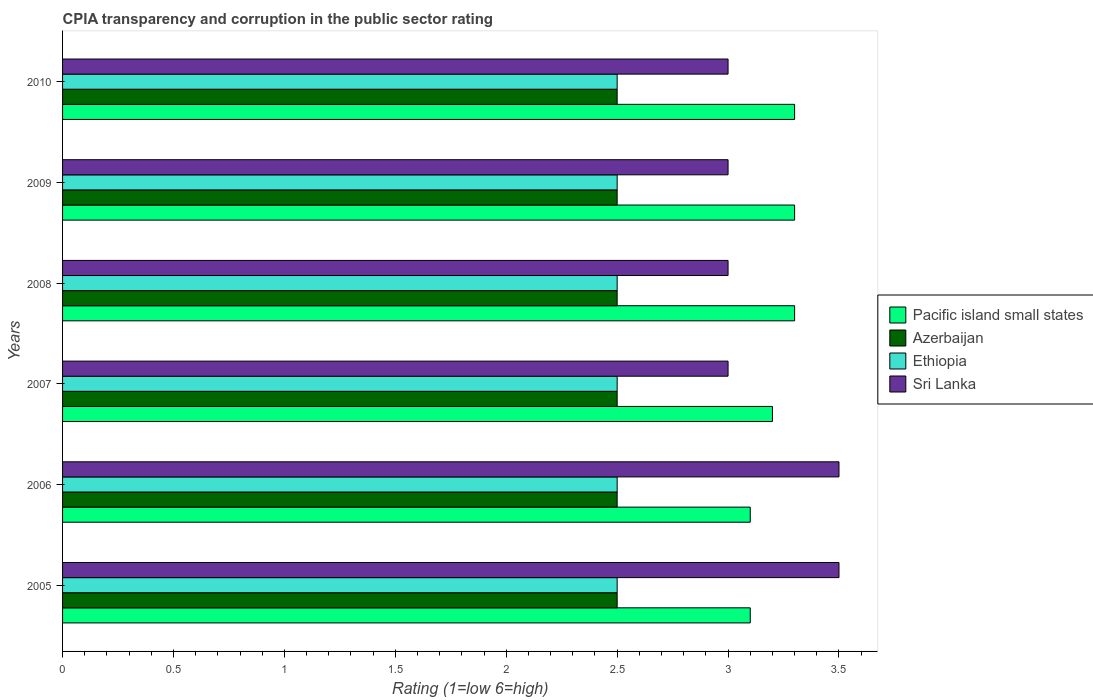How many different coloured bars are there?
Offer a very short reply. 4. Are the number of bars per tick equal to the number of legend labels?
Offer a terse response. Yes. Are the number of bars on each tick of the Y-axis equal?
Provide a short and direct response. Yes. In how many cases, is the number of bars for a given year not equal to the number of legend labels?
Ensure brevity in your answer.  0. What is the CPIA rating in Pacific island small states in 2010?
Provide a succinct answer. 3.3. In which year was the CPIA rating in Pacific island small states maximum?
Give a very brief answer. 2008. In which year was the CPIA rating in Sri Lanka minimum?
Offer a very short reply. 2007. What is the difference between the CPIA rating in Pacific island small states in 2006 and that in 2008?
Ensure brevity in your answer.  -0.2. What is the difference between the CPIA rating in Azerbaijan in 2006 and the CPIA rating in Ethiopia in 2009?
Make the answer very short. 0. What is the average CPIA rating in Azerbaijan per year?
Ensure brevity in your answer.  2.5. In the year 2005, what is the difference between the CPIA rating in Sri Lanka and CPIA rating in Ethiopia?
Your answer should be compact. 1. What is the ratio of the CPIA rating in Azerbaijan in 2005 to that in 2010?
Your answer should be very brief. 1. Is the difference between the CPIA rating in Sri Lanka in 2005 and 2010 greater than the difference between the CPIA rating in Ethiopia in 2005 and 2010?
Your answer should be compact. Yes. What is the difference between the highest and the second highest CPIA rating in Pacific island small states?
Keep it short and to the point. 0. In how many years, is the CPIA rating in Sri Lanka greater than the average CPIA rating in Sri Lanka taken over all years?
Keep it short and to the point. 2. What does the 2nd bar from the top in 2005 represents?
Provide a succinct answer. Ethiopia. What does the 1st bar from the bottom in 2009 represents?
Offer a very short reply. Pacific island small states. How many bars are there?
Offer a terse response. 24. Are all the bars in the graph horizontal?
Offer a terse response. Yes. How many years are there in the graph?
Ensure brevity in your answer.  6. What is the difference between two consecutive major ticks on the X-axis?
Give a very brief answer. 0.5. Does the graph contain any zero values?
Ensure brevity in your answer.  No. How many legend labels are there?
Make the answer very short. 4. What is the title of the graph?
Offer a terse response. CPIA transparency and corruption in the public sector rating. Does "Russian Federation" appear as one of the legend labels in the graph?
Your answer should be compact. No. What is the label or title of the X-axis?
Offer a very short reply. Rating (1=low 6=high). What is the Rating (1=low 6=high) of Ethiopia in 2005?
Keep it short and to the point. 2.5. What is the Rating (1=low 6=high) in Azerbaijan in 2006?
Make the answer very short. 2.5. What is the Rating (1=low 6=high) in Ethiopia in 2006?
Make the answer very short. 2.5. What is the Rating (1=low 6=high) in Sri Lanka in 2008?
Ensure brevity in your answer.  3. What is the Rating (1=low 6=high) of Pacific island small states in 2009?
Ensure brevity in your answer.  3.3. What is the Rating (1=low 6=high) of Ethiopia in 2009?
Your answer should be compact. 2.5. What is the Rating (1=low 6=high) of Pacific island small states in 2010?
Keep it short and to the point. 3.3. What is the Rating (1=low 6=high) in Ethiopia in 2010?
Give a very brief answer. 2.5. Across all years, what is the maximum Rating (1=low 6=high) in Pacific island small states?
Ensure brevity in your answer.  3.3. Across all years, what is the maximum Rating (1=low 6=high) in Azerbaijan?
Provide a short and direct response. 2.5. Across all years, what is the minimum Rating (1=low 6=high) in Ethiopia?
Your answer should be compact. 2.5. Across all years, what is the minimum Rating (1=low 6=high) in Sri Lanka?
Provide a succinct answer. 3. What is the total Rating (1=low 6=high) in Pacific island small states in the graph?
Make the answer very short. 19.3. What is the total Rating (1=low 6=high) of Azerbaijan in the graph?
Your response must be concise. 15. What is the total Rating (1=low 6=high) in Ethiopia in the graph?
Ensure brevity in your answer.  15. What is the difference between the Rating (1=low 6=high) of Azerbaijan in 2005 and that in 2006?
Give a very brief answer. 0. What is the difference between the Rating (1=low 6=high) in Ethiopia in 2005 and that in 2006?
Keep it short and to the point. 0. What is the difference between the Rating (1=low 6=high) in Pacific island small states in 2005 and that in 2007?
Keep it short and to the point. -0.1. What is the difference between the Rating (1=low 6=high) in Azerbaijan in 2005 and that in 2007?
Offer a very short reply. 0. What is the difference between the Rating (1=low 6=high) of Ethiopia in 2005 and that in 2007?
Offer a terse response. 0. What is the difference between the Rating (1=low 6=high) in Pacific island small states in 2005 and that in 2008?
Your answer should be compact. -0.2. What is the difference between the Rating (1=low 6=high) in Azerbaijan in 2005 and that in 2008?
Your answer should be compact. 0. What is the difference between the Rating (1=low 6=high) in Pacific island small states in 2005 and that in 2009?
Ensure brevity in your answer.  -0.2. What is the difference between the Rating (1=low 6=high) in Azerbaijan in 2005 and that in 2009?
Your response must be concise. 0. What is the difference between the Rating (1=low 6=high) in Ethiopia in 2005 and that in 2009?
Give a very brief answer. 0. What is the difference between the Rating (1=low 6=high) in Sri Lanka in 2005 and that in 2009?
Your response must be concise. 0.5. What is the difference between the Rating (1=low 6=high) in Pacific island small states in 2005 and that in 2010?
Provide a succinct answer. -0.2. What is the difference between the Rating (1=low 6=high) of Azerbaijan in 2005 and that in 2010?
Provide a short and direct response. 0. What is the difference between the Rating (1=low 6=high) in Pacific island small states in 2006 and that in 2007?
Ensure brevity in your answer.  -0.1. What is the difference between the Rating (1=low 6=high) of Azerbaijan in 2006 and that in 2007?
Your answer should be very brief. 0. What is the difference between the Rating (1=low 6=high) of Pacific island small states in 2006 and that in 2008?
Provide a short and direct response. -0.2. What is the difference between the Rating (1=low 6=high) in Pacific island small states in 2006 and that in 2009?
Your response must be concise. -0.2. What is the difference between the Rating (1=low 6=high) in Azerbaijan in 2006 and that in 2009?
Keep it short and to the point. 0. What is the difference between the Rating (1=low 6=high) in Ethiopia in 2006 and that in 2009?
Keep it short and to the point. 0. What is the difference between the Rating (1=low 6=high) of Pacific island small states in 2006 and that in 2010?
Keep it short and to the point. -0.2. What is the difference between the Rating (1=low 6=high) of Azerbaijan in 2006 and that in 2010?
Provide a succinct answer. 0. What is the difference between the Rating (1=low 6=high) in Sri Lanka in 2006 and that in 2010?
Your answer should be compact. 0.5. What is the difference between the Rating (1=low 6=high) in Azerbaijan in 2007 and that in 2008?
Provide a succinct answer. 0. What is the difference between the Rating (1=low 6=high) in Ethiopia in 2007 and that in 2008?
Your answer should be compact. 0. What is the difference between the Rating (1=low 6=high) in Sri Lanka in 2007 and that in 2008?
Your answer should be very brief. 0. What is the difference between the Rating (1=low 6=high) of Sri Lanka in 2007 and that in 2009?
Your answer should be compact. 0. What is the difference between the Rating (1=low 6=high) in Azerbaijan in 2008 and that in 2009?
Provide a succinct answer. 0. What is the difference between the Rating (1=low 6=high) in Pacific island small states in 2008 and that in 2010?
Provide a succinct answer. 0. What is the difference between the Rating (1=low 6=high) in Pacific island small states in 2009 and that in 2010?
Keep it short and to the point. 0. What is the difference between the Rating (1=low 6=high) in Azerbaijan in 2009 and that in 2010?
Offer a terse response. 0. What is the difference between the Rating (1=low 6=high) in Sri Lanka in 2009 and that in 2010?
Provide a succinct answer. 0. What is the difference between the Rating (1=low 6=high) of Pacific island small states in 2005 and the Rating (1=low 6=high) of Azerbaijan in 2006?
Provide a short and direct response. 0.6. What is the difference between the Rating (1=low 6=high) in Ethiopia in 2005 and the Rating (1=low 6=high) in Sri Lanka in 2006?
Provide a short and direct response. -1. What is the difference between the Rating (1=low 6=high) in Pacific island small states in 2005 and the Rating (1=low 6=high) in Ethiopia in 2007?
Give a very brief answer. 0.6. What is the difference between the Rating (1=low 6=high) of Pacific island small states in 2005 and the Rating (1=low 6=high) of Sri Lanka in 2007?
Your answer should be very brief. 0.1. What is the difference between the Rating (1=low 6=high) of Azerbaijan in 2005 and the Rating (1=low 6=high) of Ethiopia in 2007?
Provide a succinct answer. 0. What is the difference between the Rating (1=low 6=high) in Pacific island small states in 2005 and the Rating (1=low 6=high) in Azerbaijan in 2008?
Keep it short and to the point. 0.6. What is the difference between the Rating (1=low 6=high) of Pacific island small states in 2005 and the Rating (1=low 6=high) of Ethiopia in 2008?
Ensure brevity in your answer.  0.6. What is the difference between the Rating (1=low 6=high) in Pacific island small states in 2005 and the Rating (1=low 6=high) in Sri Lanka in 2008?
Provide a short and direct response. 0.1. What is the difference between the Rating (1=low 6=high) of Azerbaijan in 2005 and the Rating (1=low 6=high) of Ethiopia in 2008?
Your answer should be compact. 0. What is the difference between the Rating (1=low 6=high) of Pacific island small states in 2005 and the Rating (1=low 6=high) of Ethiopia in 2009?
Provide a succinct answer. 0.6. What is the difference between the Rating (1=low 6=high) of Azerbaijan in 2005 and the Rating (1=low 6=high) of Ethiopia in 2009?
Provide a short and direct response. 0. What is the difference between the Rating (1=low 6=high) of Azerbaijan in 2005 and the Rating (1=low 6=high) of Sri Lanka in 2009?
Your response must be concise. -0.5. What is the difference between the Rating (1=low 6=high) of Ethiopia in 2005 and the Rating (1=low 6=high) of Sri Lanka in 2009?
Give a very brief answer. -0.5. What is the difference between the Rating (1=low 6=high) in Pacific island small states in 2005 and the Rating (1=low 6=high) in Azerbaijan in 2010?
Your answer should be very brief. 0.6. What is the difference between the Rating (1=low 6=high) of Azerbaijan in 2005 and the Rating (1=low 6=high) of Ethiopia in 2010?
Provide a short and direct response. 0. What is the difference between the Rating (1=low 6=high) of Ethiopia in 2005 and the Rating (1=low 6=high) of Sri Lanka in 2010?
Your answer should be very brief. -0.5. What is the difference between the Rating (1=low 6=high) of Pacific island small states in 2006 and the Rating (1=low 6=high) of Sri Lanka in 2007?
Offer a terse response. 0.1. What is the difference between the Rating (1=low 6=high) in Azerbaijan in 2006 and the Rating (1=low 6=high) in Ethiopia in 2007?
Give a very brief answer. 0. What is the difference between the Rating (1=low 6=high) of Azerbaijan in 2006 and the Rating (1=low 6=high) of Sri Lanka in 2007?
Offer a terse response. -0.5. What is the difference between the Rating (1=low 6=high) in Pacific island small states in 2006 and the Rating (1=low 6=high) in Azerbaijan in 2008?
Your answer should be compact. 0.6. What is the difference between the Rating (1=low 6=high) in Pacific island small states in 2006 and the Rating (1=low 6=high) in Sri Lanka in 2008?
Your answer should be compact. 0.1. What is the difference between the Rating (1=low 6=high) in Azerbaijan in 2006 and the Rating (1=low 6=high) in Ethiopia in 2008?
Your answer should be very brief. 0. What is the difference between the Rating (1=low 6=high) in Azerbaijan in 2006 and the Rating (1=low 6=high) in Sri Lanka in 2008?
Provide a succinct answer. -0.5. What is the difference between the Rating (1=low 6=high) of Pacific island small states in 2006 and the Rating (1=low 6=high) of Ethiopia in 2009?
Provide a short and direct response. 0.6. What is the difference between the Rating (1=low 6=high) of Pacific island small states in 2006 and the Rating (1=low 6=high) of Sri Lanka in 2009?
Offer a very short reply. 0.1. What is the difference between the Rating (1=low 6=high) of Azerbaijan in 2006 and the Rating (1=low 6=high) of Ethiopia in 2009?
Your answer should be compact. 0. What is the difference between the Rating (1=low 6=high) of Ethiopia in 2006 and the Rating (1=low 6=high) of Sri Lanka in 2009?
Provide a short and direct response. -0.5. What is the difference between the Rating (1=low 6=high) in Ethiopia in 2006 and the Rating (1=low 6=high) in Sri Lanka in 2010?
Provide a succinct answer. -0.5. What is the difference between the Rating (1=low 6=high) in Pacific island small states in 2007 and the Rating (1=low 6=high) in Ethiopia in 2008?
Your response must be concise. 0.7. What is the difference between the Rating (1=low 6=high) of Azerbaijan in 2007 and the Rating (1=low 6=high) of Ethiopia in 2008?
Provide a succinct answer. 0. What is the difference between the Rating (1=low 6=high) in Pacific island small states in 2007 and the Rating (1=low 6=high) in Ethiopia in 2009?
Make the answer very short. 0.7. What is the difference between the Rating (1=low 6=high) in Pacific island small states in 2007 and the Rating (1=low 6=high) in Sri Lanka in 2009?
Offer a very short reply. 0.2. What is the difference between the Rating (1=low 6=high) of Azerbaijan in 2007 and the Rating (1=low 6=high) of Ethiopia in 2009?
Offer a very short reply. 0. What is the difference between the Rating (1=low 6=high) in Azerbaijan in 2007 and the Rating (1=low 6=high) in Sri Lanka in 2009?
Ensure brevity in your answer.  -0.5. What is the difference between the Rating (1=low 6=high) of Ethiopia in 2007 and the Rating (1=low 6=high) of Sri Lanka in 2009?
Provide a succinct answer. -0.5. What is the difference between the Rating (1=low 6=high) in Pacific island small states in 2007 and the Rating (1=low 6=high) in Azerbaijan in 2010?
Your answer should be compact. 0.7. What is the difference between the Rating (1=low 6=high) of Azerbaijan in 2007 and the Rating (1=low 6=high) of Sri Lanka in 2010?
Offer a very short reply. -0.5. What is the difference between the Rating (1=low 6=high) in Pacific island small states in 2008 and the Rating (1=low 6=high) in Azerbaijan in 2009?
Your answer should be very brief. 0.8. What is the difference between the Rating (1=low 6=high) of Azerbaijan in 2008 and the Rating (1=low 6=high) of Ethiopia in 2009?
Offer a terse response. 0. What is the difference between the Rating (1=low 6=high) of Azerbaijan in 2008 and the Rating (1=low 6=high) of Ethiopia in 2010?
Make the answer very short. 0. What is the difference between the Rating (1=low 6=high) in Azerbaijan in 2008 and the Rating (1=low 6=high) in Sri Lanka in 2010?
Give a very brief answer. -0.5. What is the difference between the Rating (1=low 6=high) of Pacific island small states in 2009 and the Rating (1=low 6=high) of Azerbaijan in 2010?
Make the answer very short. 0.8. What is the difference between the Rating (1=low 6=high) of Pacific island small states in 2009 and the Rating (1=low 6=high) of Sri Lanka in 2010?
Offer a terse response. 0.3. What is the difference between the Rating (1=low 6=high) of Azerbaijan in 2009 and the Rating (1=low 6=high) of Sri Lanka in 2010?
Provide a succinct answer. -0.5. What is the difference between the Rating (1=low 6=high) of Ethiopia in 2009 and the Rating (1=low 6=high) of Sri Lanka in 2010?
Keep it short and to the point. -0.5. What is the average Rating (1=low 6=high) of Pacific island small states per year?
Your answer should be very brief. 3.22. What is the average Rating (1=low 6=high) in Azerbaijan per year?
Your answer should be very brief. 2.5. What is the average Rating (1=low 6=high) in Sri Lanka per year?
Offer a very short reply. 3.17. In the year 2005, what is the difference between the Rating (1=low 6=high) in Pacific island small states and Rating (1=low 6=high) in Ethiopia?
Offer a very short reply. 0.6. In the year 2005, what is the difference between the Rating (1=low 6=high) in Azerbaijan and Rating (1=low 6=high) in Sri Lanka?
Ensure brevity in your answer.  -1. In the year 2006, what is the difference between the Rating (1=low 6=high) of Azerbaijan and Rating (1=low 6=high) of Ethiopia?
Make the answer very short. 0. In the year 2006, what is the difference between the Rating (1=low 6=high) in Azerbaijan and Rating (1=low 6=high) in Sri Lanka?
Your response must be concise. -1. In the year 2007, what is the difference between the Rating (1=low 6=high) in Ethiopia and Rating (1=low 6=high) in Sri Lanka?
Give a very brief answer. -0.5. In the year 2008, what is the difference between the Rating (1=low 6=high) in Pacific island small states and Rating (1=low 6=high) in Azerbaijan?
Offer a terse response. 0.8. In the year 2008, what is the difference between the Rating (1=low 6=high) of Pacific island small states and Rating (1=low 6=high) of Ethiopia?
Ensure brevity in your answer.  0.8. In the year 2008, what is the difference between the Rating (1=low 6=high) of Pacific island small states and Rating (1=low 6=high) of Sri Lanka?
Ensure brevity in your answer.  0.3. In the year 2008, what is the difference between the Rating (1=low 6=high) in Azerbaijan and Rating (1=low 6=high) in Sri Lanka?
Your answer should be very brief. -0.5. In the year 2008, what is the difference between the Rating (1=low 6=high) in Ethiopia and Rating (1=low 6=high) in Sri Lanka?
Keep it short and to the point. -0.5. In the year 2009, what is the difference between the Rating (1=low 6=high) of Pacific island small states and Rating (1=low 6=high) of Azerbaijan?
Provide a succinct answer. 0.8. In the year 2009, what is the difference between the Rating (1=low 6=high) of Pacific island small states and Rating (1=low 6=high) of Ethiopia?
Offer a terse response. 0.8. In the year 2009, what is the difference between the Rating (1=low 6=high) in Azerbaijan and Rating (1=low 6=high) in Ethiopia?
Keep it short and to the point. 0. In the year 2009, what is the difference between the Rating (1=low 6=high) in Azerbaijan and Rating (1=low 6=high) in Sri Lanka?
Ensure brevity in your answer.  -0.5. In the year 2009, what is the difference between the Rating (1=low 6=high) of Ethiopia and Rating (1=low 6=high) of Sri Lanka?
Ensure brevity in your answer.  -0.5. In the year 2010, what is the difference between the Rating (1=low 6=high) in Pacific island small states and Rating (1=low 6=high) in Azerbaijan?
Your answer should be very brief. 0.8. In the year 2010, what is the difference between the Rating (1=low 6=high) in Azerbaijan and Rating (1=low 6=high) in Ethiopia?
Keep it short and to the point. 0. In the year 2010, what is the difference between the Rating (1=low 6=high) in Ethiopia and Rating (1=low 6=high) in Sri Lanka?
Make the answer very short. -0.5. What is the ratio of the Rating (1=low 6=high) in Pacific island small states in 2005 to that in 2006?
Provide a succinct answer. 1. What is the ratio of the Rating (1=low 6=high) in Azerbaijan in 2005 to that in 2006?
Ensure brevity in your answer.  1. What is the ratio of the Rating (1=low 6=high) of Ethiopia in 2005 to that in 2006?
Make the answer very short. 1. What is the ratio of the Rating (1=low 6=high) of Sri Lanka in 2005 to that in 2006?
Keep it short and to the point. 1. What is the ratio of the Rating (1=low 6=high) in Pacific island small states in 2005 to that in 2007?
Make the answer very short. 0.97. What is the ratio of the Rating (1=low 6=high) in Azerbaijan in 2005 to that in 2007?
Provide a short and direct response. 1. What is the ratio of the Rating (1=low 6=high) of Ethiopia in 2005 to that in 2007?
Give a very brief answer. 1. What is the ratio of the Rating (1=low 6=high) in Pacific island small states in 2005 to that in 2008?
Provide a short and direct response. 0.94. What is the ratio of the Rating (1=low 6=high) in Pacific island small states in 2005 to that in 2009?
Provide a succinct answer. 0.94. What is the ratio of the Rating (1=low 6=high) in Ethiopia in 2005 to that in 2009?
Keep it short and to the point. 1. What is the ratio of the Rating (1=low 6=high) of Sri Lanka in 2005 to that in 2009?
Offer a very short reply. 1.17. What is the ratio of the Rating (1=low 6=high) of Pacific island small states in 2005 to that in 2010?
Your answer should be compact. 0.94. What is the ratio of the Rating (1=low 6=high) in Pacific island small states in 2006 to that in 2007?
Your answer should be compact. 0.97. What is the ratio of the Rating (1=low 6=high) of Azerbaijan in 2006 to that in 2007?
Your answer should be compact. 1. What is the ratio of the Rating (1=low 6=high) in Ethiopia in 2006 to that in 2007?
Ensure brevity in your answer.  1. What is the ratio of the Rating (1=low 6=high) of Sri Lanka in 2006 to that in 2007?
Give a very brief answer. 1.17. What is the ratio of the Rating (1=low 6=high) in Pacific island small states in 2006 to that in 2008?
Give a very brief answer. 0.94. What is the ratio of the Rating (1=low 6=high) of Azerbaijan in 2006 to that in 2008?
Provide a short and direct response. 1. What is the ratio of the Rating (1=low 6=high) of Ethiopia in 2006 to that in 2008?
Ensure brevity in your answer.  1. What is the ratio of the Rating (1=low 6=high) of Sri Lanka in 2006 to that in 2008?
Your response must be concise. 1.17. What is the ratio of the Rating (1=low 6=high) of Pacific island small states in 2006 to that in 2009?
Your answer should be very brief. 0.94. What is the ratio of the Rating (1=low 6=high) of Ethiopia in 2006 to that in 2009?
Your response must be concise. 1. What is the ratio of the Rating (1=low 6=high) in Sri Lanka in 2006 to that in 2009?
Keep it short and to the point. 1.17. What is the ratio of the Rating (1=low 6=high) in Pacific island small states in 2006 to that in 2010?
Offer a very short reply. 0.94. What is the ratio of the Rating (1=low 6=high) in Azerbaijan in 2006 to that in 2010?
Offer a very short reply. 1. What is the ratio of the Rating (1=low 6=high) of Ethiopia in 2006 to that in 2010?
Make the answer very short. 1. What is the ratio of the Rating (1=low 6=high) of Sri Lanka in 2006 to that in 2010?
Offer a terse response. 1.17. What is the ratio of the Rating (1=low 6=high) in Pacific island small states in 2007 to that in 2008?
Ensure brevity in your answer.  0.97. What is the ratio of the Rating (1=low 6=high) in Azerbaijan in 2007 to that in 2008?
Give a very brief answer. 1. What is the ratio of the Rating (1=low 6=high) in Pacific island small states in 2007 to that in 2009?
Your response must be concise. 0.97. What is the ratio of the Rating (1=low 6=high) of Azerbaijan in 2007 to that in 2009?
Your response must be concise. 1. What is the ratio of the Rating (1=low 6=high) of Pacific island small states in 2007 to that in 2010?
Offer a very short reply. 0.97. What is the ratio of the Rating (1=low 6=high) in Sri Lanka in 2007 to that in 2010?
Provide a succinct answer. 1. What is the ratio of the Rating (1=low 6=high) of Sri Lanka in 2008 to that in 2009?
Provide a succinct answer. 1. What is the ratio of the Rating (1=low 6=high) of Azerbaijan in 2008 to that in 2010?
Make the answer very short. 1. What is the ratio of the Rating (1=low 6=high) in Ethiopia in 2008 to that in 2010?
Give a very brief answer. 1. What is the ratio of the Rating (1=low 6=high) of Pacific island small states in 2009 to that in 2010?
Provide a succinct answer. 1. What is the ratio of the Rating (1=low 6=high) in Azerbaijan in 2009 to that in 2010?
Offer a terse response. 1. What is the ratio of the Rating (1=low 6=high) in Ethiopia in 2009 to that in 2010?
Ensure brevity in your answer.  1. What is the ratio of the Rating (1=low 6=high) in Sri Lanka in 2009 to that in 2010?
Give a very brief answer. 1. What is the difference between the highest and the second highest Rating (1=low 6=high) in Ethiopia?
Make the answer very short. 0. What is the difference between the highest and the lowest Rating (1=low 6=high) of Azerbaijan?
Keep it short and to the point. 0. What is the difference between the highest and the lowest Rating (1=low 6=high) of Sri Lanka?
Your answer should be very brief. 0.5. 